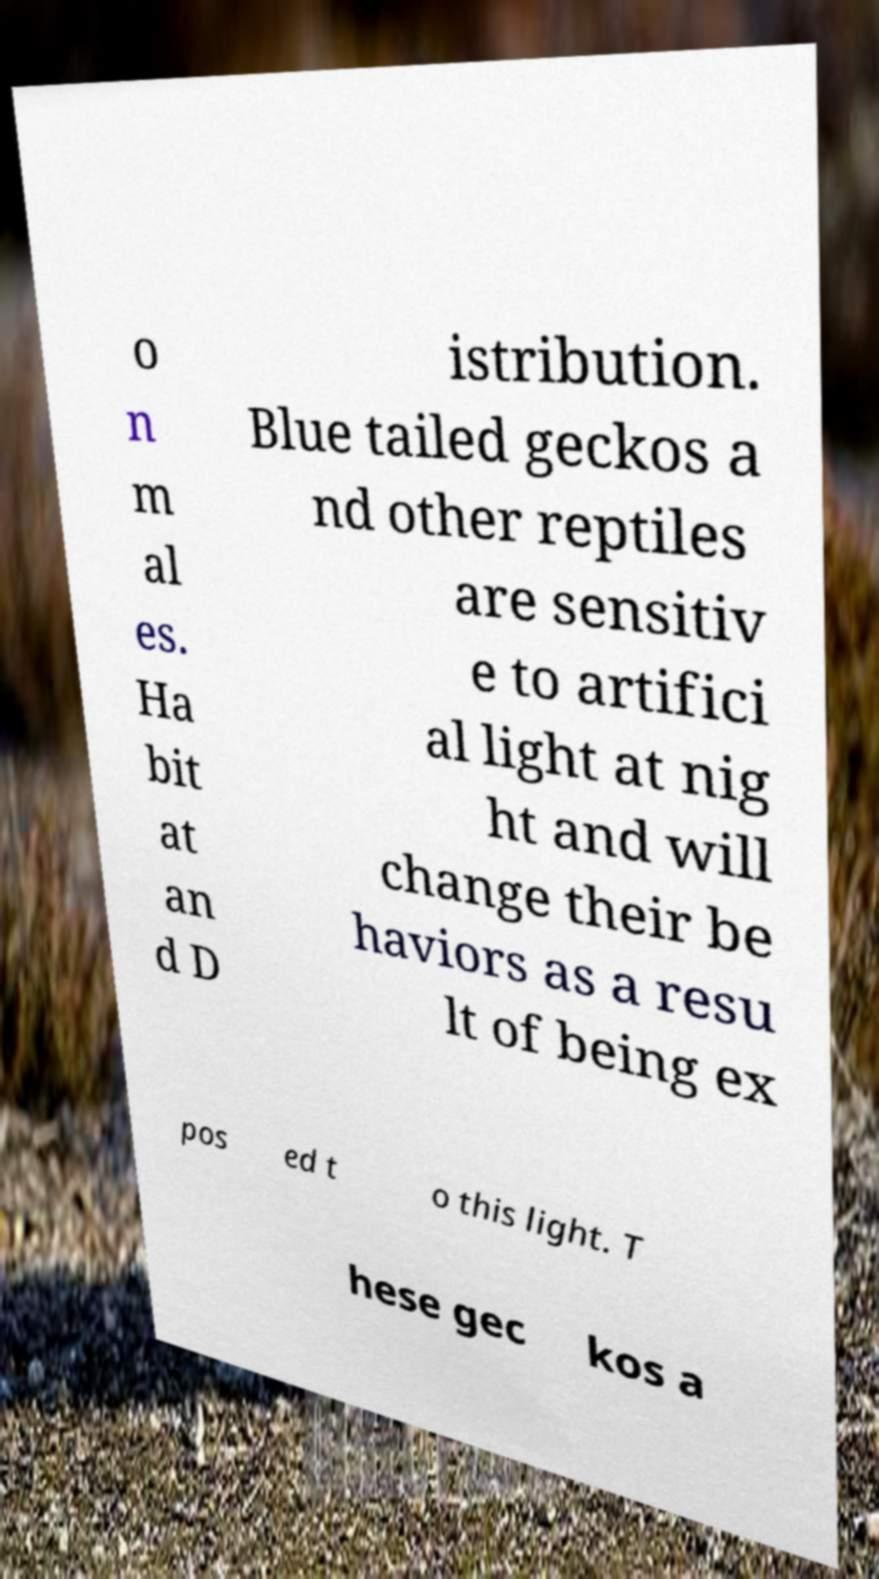Please identify and transcribe the text found in this image. o n m al es. Ha bit at an d D istribution. Blue tailed geckos a nd other reptiles are sensitiv e to artifici al light at nig ht and will change their be haviors as a resu lt of being ex pos ed t o this light. T hese gec kos a 